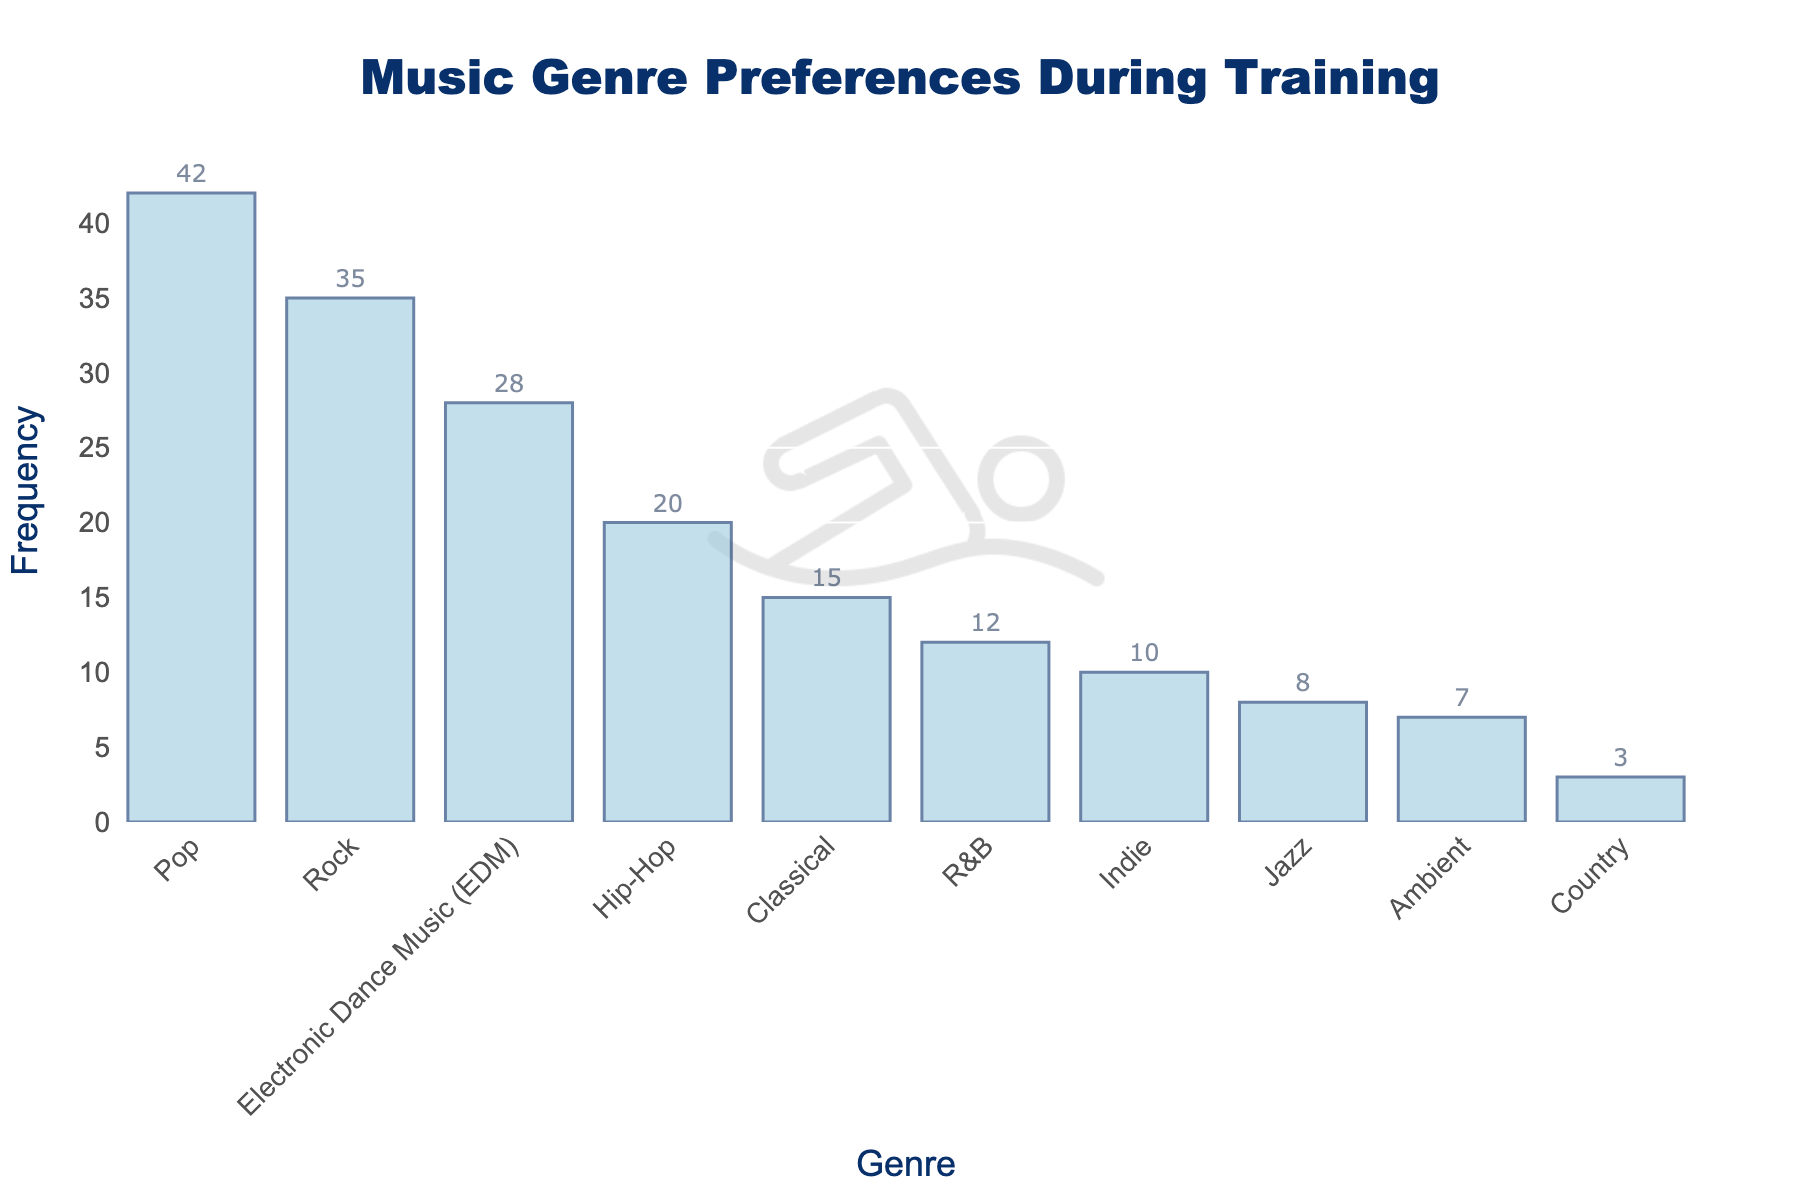What is the title of the figure? The title of the figure is displayed at the top and reads, "Music Genre Preferences During Training".
Answer: Music Genre Preferences During Training Which genre has the highest frequency? By looking at the tallest bar in the histogram, the genre with the highest frequency is Pop with a frequency of 42.
Answer: Pop What is the frequency of Classical music? The bar corresponding to Classical music reaches up to the value 15 on the y-axis.
Answer: 15 How many genres have a frequency greater than 20? By checking each bar, Pop, Rock, and EDM each have a frequency greater than 20 (42, 35, and 28 respectively). That's a total of 3 genres.
Answer: 3 What is the total frequency of Rock and Hip-Hop combined? Rock has a frequency of 35 and Hip-Hop has a frequency of 20. Adding these together, 35 + 20 = 55.
Answer: 55 Which genre has the lowest frequency? The shortest bar in the histogram represents the genre with the lowest frequency, which is Country with a frequency of 3.
Answer: Country Is the frequency of Hip-Hop higher or lower than EDM? The bar representing Hip-Hop reaches up to 20 on the y-axis, while the bar for EDM reaches up to 28, so Hip-Hop has a lower frequency than EDM.
Answer: Lower What is the median frequency of all genres? To find the median, list all frequencies in order: 3, 7, 8, 10, 12, 15, 20, 28, 35, 42. Since there are 10 data points, the median is the average of the 5th and 6th values: (12 + 15) / 2 = 13.5.
Answer: 13.5 How much greater is the frequency of Pop compared to Jazz? Pop has a frequency of 42 and Jazz has a frequency of 8. The difference is 42 - 8 = 34.
Answer: 34 What is the average frequency of the genres listed? Sum all frequencies: 42 + 35 + 28 + 20 + 15 + 12 + 10 + 8 + 7 + 3 = 180. There are 10 genres, so the average is 180 / 10 = 18.
Answer: 18 